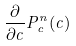<formula> <loc_0><loc_0><loc_500><loc_500>\frac { \partial } { \partial c } P _ { c } ^ { n } ( c )</formula> 